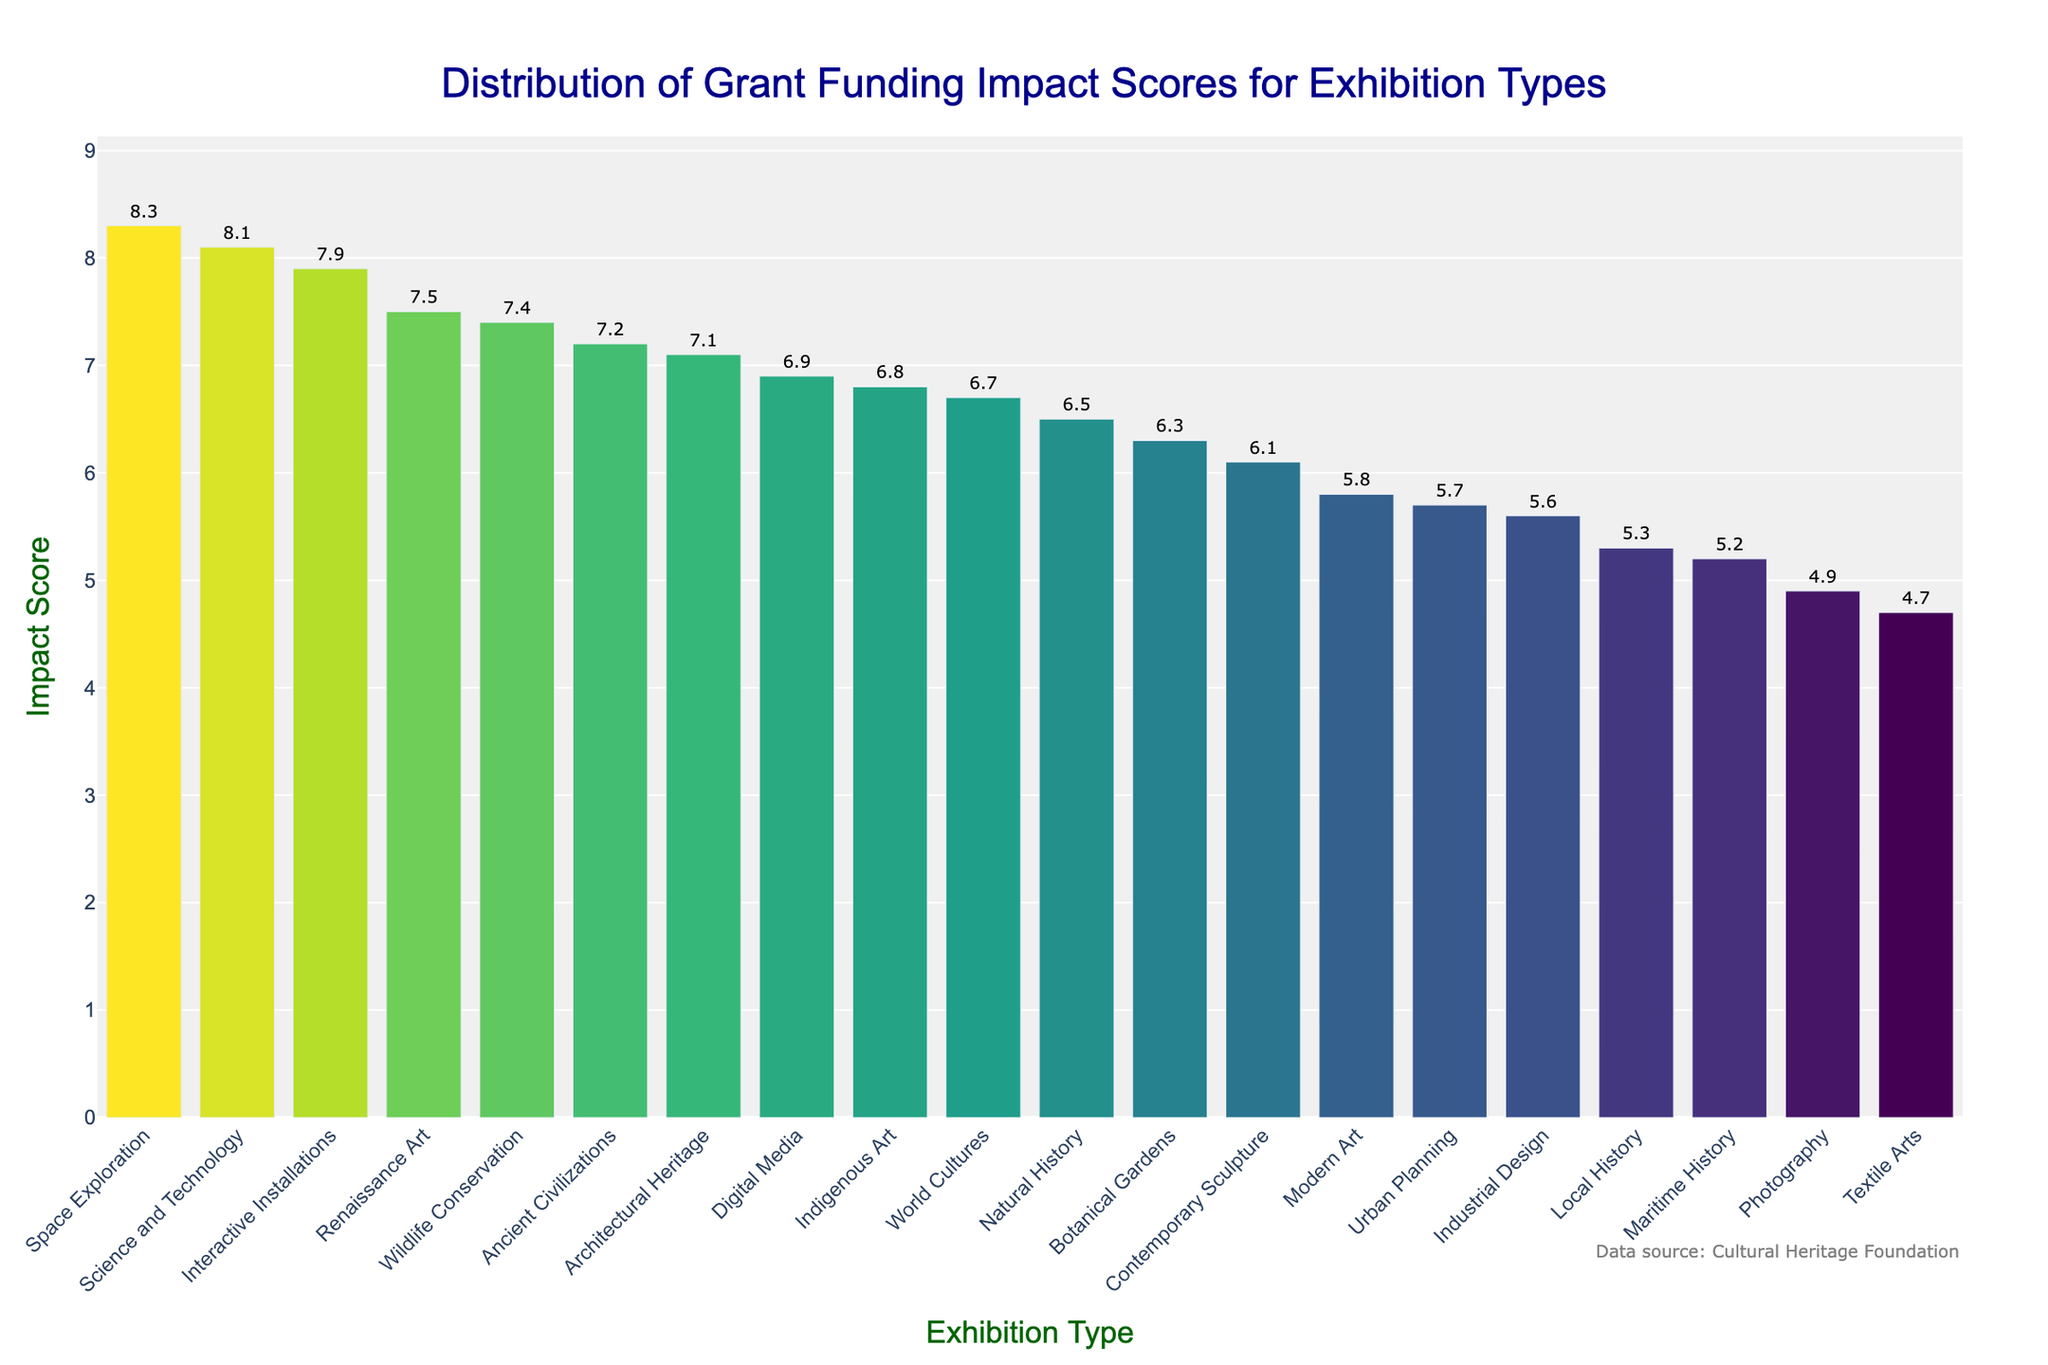What is the title of the plot? The title of the plot is clearly displayed at the top center of the figure.
Answer: Distribution of Grant Funding Impact Scores for Exhibition Types What does the x-axis represent? The x-axis represents the various types of exhibitions.
Answer: Exhibition Type What is the highest impact score, and which exhibition type does it correspond to? By observing the tallest bar and its corresponding label, you can identify the highest impact score and the exhibition type.
Answer: 8.3, Space Exploration What is the average impact score of all the exhibition types? To find the average, sum all the impact scores and divide by the number of exhibition types. Sum = 122.8, Count = 20, Average = 122.8 / 20 = 6.14.
Answer: 6.14 How does the impact score of "Modern Art" compare to "Industrial Design"? Compare the heights and values of the bars corresponding to "Modern Art" and "Industrial Design". Modern Art is 5.8; Industrial Design is 5.6.
Answer: Modern Art score is 0.2 higher than Industrial Design Which exhibition types have an impact score greater than 7.0? Identify bars that exceed the 7.0 mark on the y-axis and refer to their labels.
Answer: Ancient Civilizations, Renaissance Art, Architectural Heritage, Wildlife Conservation, Interactive Installations, Space Exploration What is the median impact score of the exhibition types? List all impact scores in ascending order and find the middle value(s). The sorted scores are: 4.7, 4.9, 5.2, 5.3, 5.6, 5.7, 5.8, 6.1, 6.3, 6.5, 6.7, 6.8, 6.9, 7.1, 7.2, 7.4, 7.5, 7.9, 8.1, 8.3. Median is (6.7 + 6.8) / 2 = 6.75.
Answer: 6.75 What is the total number of exhibition types included in the plot? Count all unique labels on the x-axis.
Answer: 20 Which exhibition type has the lowest impact score? Identify the shortest bar and its corresponding label.
Answer: Textile Arts How does the impact score distribution appear overall? By observing the heights, spread, and patterns of the bars, you can describe the general trend.
Answer: The impact scores vary, with both high and low values, but no extreme outliers Is the impact score of "Textile Arts" above or below the average impact score? Compare the impact score of "Textile Arts" (4.7) with the calculated average impact score (6.14).
Answer: Below 